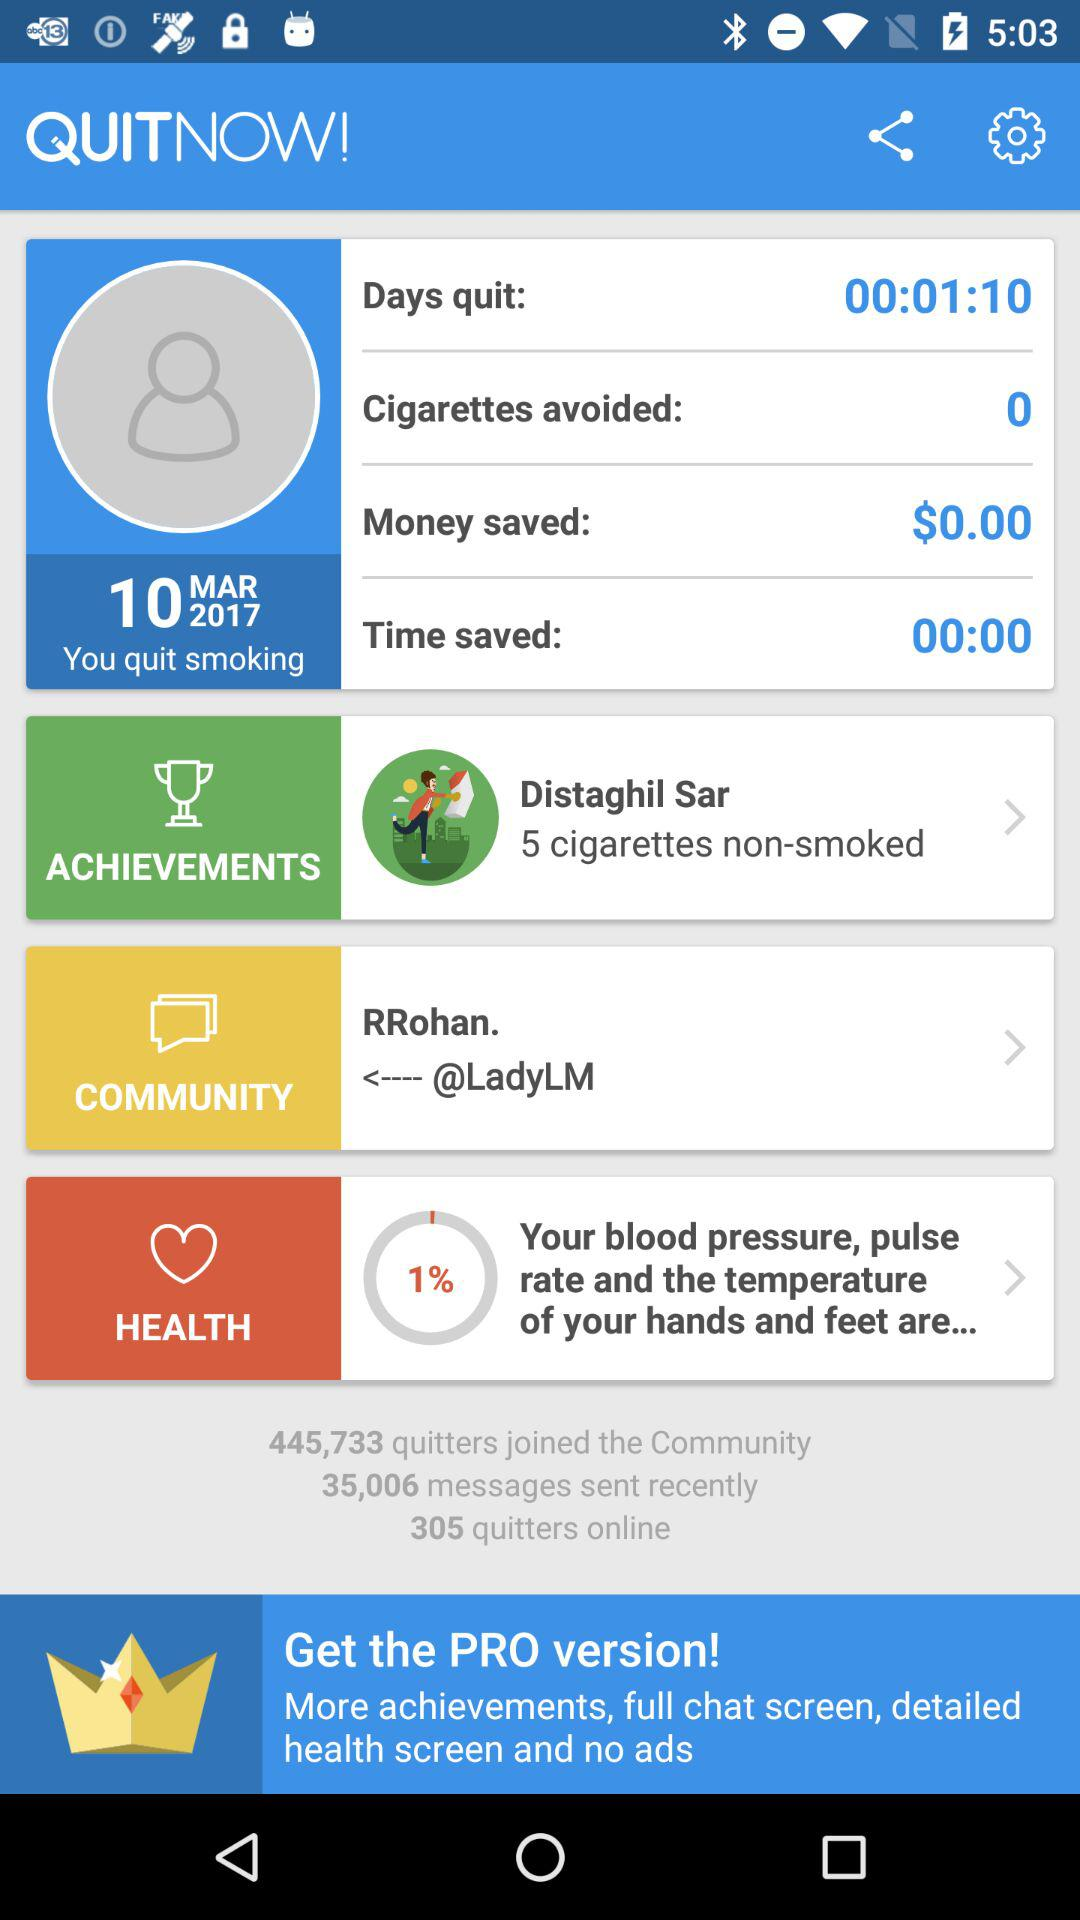How much money have I saved by quitting smoking?
Answer the question using a single word or phrase. $0.00 